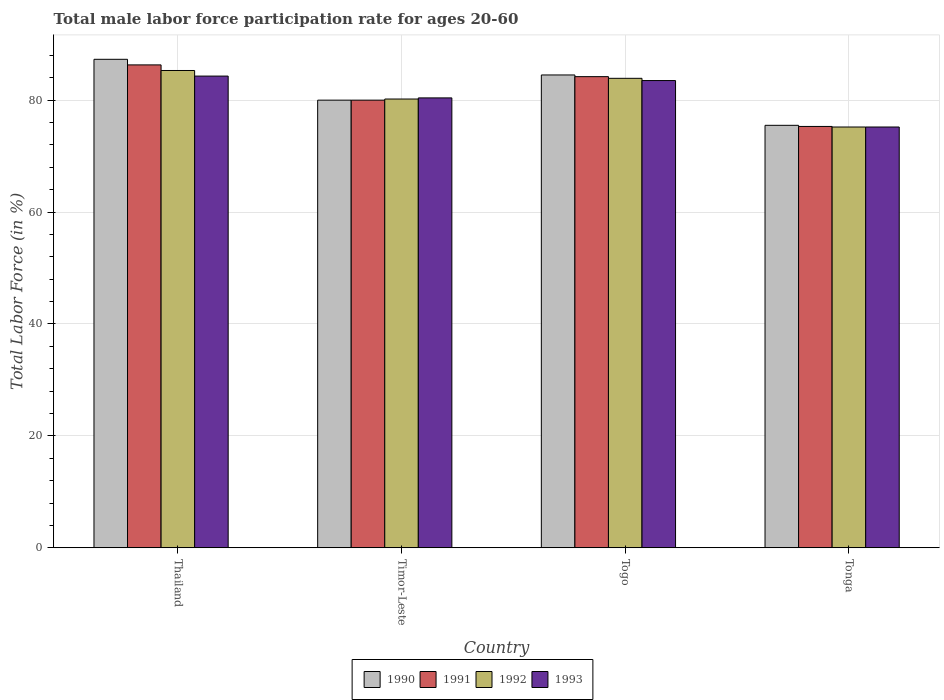How many groups of bars are there?
Offer a terse response. 4. What is the label of the 1st group of bars from the left?
Your answer should be compact. Thailand. In how many cases, is the number of bars for a given country not equal to the number of legend labels?
Provide a short and direct response. 0. What is the male labor force participation rate in 1991 in Thailand?
Offer a terse response. 86.3. Across all countries, what is the maximum male labor force participation rate in 1990?
Your response must be concise. 87.3. Across all countries, what is the minimum male labor force participation rate in 1992?
Provide a succinct answer. 75.2. In which country was the male labor force participation rate in 1993 maximum?
Provide a succinct answer. Thailand. In which country was the male labor force participation rate in 1993 minimum?
Give a very brief answer. Tonga. What is the total male labor force participation rate in 1990 in the graph?
Provide a succinct answer. 327.3. What is the difference between the male labor force participation rate in 1991 in Thailand and that in Togo?
Make the answer very short. 2.1. What is the difference between the male labor force participation rate in 1993 in Timor-Leste and the male labor force participation rate in 1992 in Togo?
Your answer should be compact. -3.5. What is the average male labor force participation rate in 1992 per country?
Make the answer very short. 81.15. What is the difference between the male labor force participation rate of/in 1992 and male labor force participation rate of/in 1991 in Thailand?
Provide a succinct answer. -1. In how many countries, is the male labor force participation rate in 1990 greater than 40 %?
Offer a very short reply. 4. What is the ratio of the male labor force participation rate in 1993 in Togo to that in Tonga?
Offer a very short reply. 1.11. Is the male labor force participation rate in 1993 in Timor-Leste less than that in Togo?
Make the answer very short. Yes. Is the difference between the male labor force participation rate in 1992 in Togo and Tonga greater than the difference between the male labor force participation rate in 1991 in Togo and Tonga?
Offer a very short reply. No. What is the difference between the highest and the lowest male labor force participation rate in 1992?
Your response must be concise. 10.1. In how many countries, is the male labor force participation rate in 1993 greater than the average male labor force participation rate in 1993 taken over all countries?
Offer a terse response. 2. Is it the case that in every country, the sum of the male labor force participation rate in 1991 and male labor force participation rate in 1992 is greater than the sum of male labor force participation rate in 1990 and male labor force participation rate in 1993?
Your answer should be compact. No. Is it the case that in every country, the sum of the male labor force participation rate in 1992 and male labor force participation rate in 1991 is greater than the male labor force participation rate in 1990?
Offer a very short reply. Yes. How many bars are there?
Your answer should be very brief. 16. Are all the bars in the graph horizontal?
Your answer should be very brief. No. Does the graph contain grids?
Your answer should be compact. Yes. Where does the legend appear in the graph?
Keep it short and to the point. Bottom center. How many legend labels are there?
Your answer should be very brief. 4. What is the title of the graph?
Ensure brevity in your answer.  Total male labor force participation rate for ages 20-60. Does "1971" appear as one of the legend labels in the graph?
Your response must be concise. No. What is the label or title of the X-axis?
Your response must be concise. Country. What is the Total Labor Force (in %) in 1990 in Thailand?
Provide a succinct answer. 87.3. What is the Total Labor Force (in %) in 1991 in Thailand?
Ensure brevity in your answer.  86.3. What is the Total Labor Force (in %) of 1992 in Thailand?
Offer a very short reply. 85.3. What is the Total Labor Force (in %) of 1993 in Thailand?
Provide a succinct answer. 84.3. What is the Total Labor Force (in %) in 1990 in Timor-Leste?
Your answer should be compact. 80. What is the Total Labor Force (in %) of 1992 in Timor-Leste?
Your response must be concise. 80.2. What is the Total Labor Force (in %) in 1993 in Timor-Leste?
Keep it short and to the point. 80.4. What is the Total Labor Force (in %) of 1990 in Togo?
Offer a terse response. 84.5. What is the Total Labor Force (in %) of 1991 in Togo?
Your answer should be very brief. 84.2. What is the Total Labor Force (in %) of 1992 in Togo?
Make the answer very short. 83.9. What is the Total Labor Force (in %) of 1993 in Togo?
Your answer should be compact. 83.5. What is the Total Labor Force (in %) of 1990 in Tonga?
Provide a short and direct response. 75.5. What is the Total Labor Force (in %) of 1991 in Tonga?
Keep it short and to the point. 75.3. What is the Total Labor Force (in %) of 1992 in Tonga?
Give a very brief answer. 75.2. What is the Total Labor Force (in %) of 1993 in Tonga?
Make the answer very short. 75.2. Across all countries, what is the maximum Total Labor Force (in %) in 1990?
Offer a very short reply. 87.3. Across all countries, what is the maximum Total Labor Force (in %) in 1991?
Make the answer very short. 86.3. Across all countries, what is the maximum Total Labor Force (in %) of 1992?
Keep it short and to the point. 85.3. Across all countries, what is the maximum Total Labor Force (in %) of 1993?
Give a very brief answer. 84.3. Across all countries, what is the minimum Total Labor Force (in %) of 1990?
Give a very brief answer. 75.5. Across all countries, what is the minimum Total Labor Force (in %) in 1991?
Ensure brevity in your answer.  75.3. Across all countries, what is the minimum Total Labor Force (in %) in 1992?
Offer a terse response. 75.2. Across all countries, what is the minimum Total Labor Force (in %) of 1993?
Ensure brevity in your answer.  75.2. What is the total Total Labor Force (in %) of 1990 in the graph?
Provide a succinct answer. 327.3. What is the total Total Labor Force (in %) of 1991 in the graph?
Give a very brief answer. 325.8. What is the total Total Labor Force (in %) in 1992 in the graph?
Offer a very short reply. 324.6. What is the total Total Labor Force (in %) of 1993 in the graph?
Provide a succinct answer. 323.4. What is the difference between the Total Labor Force (in %) in 1991 in Thailand and that in Timor-Leste?
Ensure brevity in your answer.  6.3. What is the difference between the Total Labor Force (in %) in 1992 in Thailand and that in Timor-Leste?
Offer a terse response. 5.1. What is the difference between the Total Labor Force (in %) of 1993 in Thailand and that in Timor-Leste?
Keep it short and to the point. 3.9. What is the difference between the Total Labor Force (in %) of 1991 in Thailand and that in Togo?
Provide a short and direct response. 2.1. What is the difference between the Total Labor Force (in %) of 1992 in Thailand and that in Togo?
Your answer should be very brief. 1.4. What is the difference between the Total Labor Force (in %) in 1993 in Thailand and that in Togo?
Give a very brief answer. 0.8. What is the difference between the Total Labor Force (in %) of 1990 in Thailand and that in Tonga?
Provide a short and direct response. 11.8. What is the difference between the Total Labor Force (in %) in 1991 in Thailand and that in Tonga?
Your response must be concise. 11. What is the difference between the Total Labor Force (in %) of 1992 in Thailand and that in Tonga?
Offer a terse response. 10.1. What is the difference between the Total Labor Force (in %) in 1990 in Timor-Leste and that in Togo?
Keep it short and to the point. -4.5. What is the difference between the Total Labor Force (in %) of 1992 in Timor-Leste and that in Togo?
Keep it short and to the point. -3.7. What is the difference between the Total Labor Force (in %) in 1993 in Timor-Leste and that in Togo?
Provide a succinct answer. -3.1. What is the difference between the Total Labor Force (in %) of 1991 in Timor-Leste and that in Tonga?
Your response must be concise. 4.7. What is the difference between the Total Labor Force (in %) in 1992 in Timor-Leste and that in Tonga?
Your answer should be compact. 5. What is the difference between the Total Labor Force (in %) of 1993 in Timor-Leste and that in Tonga?
Keep it short and to the point. 5.2. What is the difference between the Total Labor Force (in %) of 1990 in Togo and that in Tonga?
Provide a succinct answer. 9. What is the difference between the Total Labor Force (in %) of 1991 in Togo and that in Tonga?
Keep it short and to the point. 8.9. What is the difference between the Total Labor Force (in %) in 1990 in Thailand and the Total Labor Force (in %) in 1992 in Timor-Leste?
Provide a short and direct response. 7.1. What is the difference between the Total Labor Force (in %) in 1991 in Thailand and the Total Labor Force (in %) in 1992 in Timor-Leste?
Give a very brief answer. 6.1. What is the difference between the Total Labor Force (in %) of 1991 in Thailand and the Total Labor Force (in %) of 1993 in Timor-Leste?
Give a very brief answer. 5.9. What is the difference between the Total Labor Force (in %) of 1992 in Thailand and the Total Labor Force (in %) of 1993 in Timor-Leste?
Provide a short and direct response. 4.9. What is the difference between the Total Labor Force (in %) in 1990 in Thailand and the Total Labor Force (in %) in 1992 in Togo?
Provide a succinct answer. 3.4. What is the difference between the Total Labor Force (in %) in 1990 in Thailand and the Total Labor Force (in %) in 1993 in Togo?
Keep it short and to the point. 3.8. What is the difference between the Total Labor Force (in %) in 1992 in Thailand and the Total Labor Force (in %) in 1993 in Togo?
Your answer should be very brief. 1.8. What is the difference between the Total Labor Force (in %) of 1990 in Thailand and the Total Labor Force (in %) of 1991 in Tonga?
Provide a short and direct response. 12. What is the difference between the Total Labor Force (in %) of 1991 in Thailand and the Total Labor Force (in %) of 1992 in Tonga?
Provide a short and direct response. 11.1. What is the difference between the Total Labor Force (in %) of 1991 in Thailand and the Total Labor Force (in %) of 1993 in Tonga?
Make the answer very short. 11.1. What is the difference between the Total Labor Force (in %) in 1990 in Timor-Leste and the Total Labor Force (in %) in 1993 in Togo?
Keep it short and to the point. -3.5. What is the difference between the Total Labor Force (in %) of 1991 in Timor-Leste and the Total Labor Force (in %) of 1992 in Togo?
Offer a terse response. -3.9. What is the difference between the Total Labor Force (in %) in 1991 in Timor-Leste and the Total Labor Force (in %) in 1993 in Togo?
Your response must be concise. -3.5. What is the difference between the Total Labor Force (in %) of 1990 in Timor-Leste and the Total Labor Force (in %) of 1992 in Tonga?
Give a very brief answer. 4.8. What is the difference between the Total Labor Force (in %) of 1990 in Togo and the Total Labor Force (in %) of 1991 in Tonga?
Give a very brief answer. 9.2. What is the difference between the Total Labor Force (in %) of 1990 in Togo and the Total Labor Force (in %) of 1992 in Tonga?
Provide a short and direct response. 9.3. What is the difference between the Total Labor Force (in %) in 1990 in Togo and the Total Labor Force (in %) in 1993 in Tonga?
Provide a succinct answer. 9.3. What is the difference between the Total Labor Force (in %) of 1991 in Togo and the Total Labor Force (in %) of 1993 in Tonga?
Provide a succinct answer. 9. What is the difference between the Total Labor Force (in %) of 1992 in Togo and the Total Labor Force (in %) of 1993 in Tonga?
Offer a very short reply. 8.7. What is the average Total Labor Force (in %) in 1990 per country?
Your answer should be very brief. 81.83. What is the average Total Labor Force (in %) in 1991 per country?
Offer a very short reply. 81.45. What is the average Total Labor Force (in %) in 1992 per country?
Offer a very short reply. 81.15. What is the average Total Labor Force (in %) in 1993 per country?
Provide a succinct answer. 80.85. What is the difference between the Total Labor Force (in %) of 1990 and Total Labor Force (in %) of 1992 in Thailand?
Your answer should be very brief. 2. What is the difference between the Total Labor Force (in %) of 1990 and Total Labor Force (in %) of 1993 in Thailand?
Your answer should be very brief. 3. What is the difference between the Total Labor Force (in %) of 1991 and Total Labor Force (in %) of 1993 in Thailand?
Your answer should be very brief. 2. What is the difference between the Total Labor Force (in %) of 1992 and Total Labor Force (in %) of 1993 in Thailand?
Your answer should be very brief. 1. What is the difference between the Total Labor Force (in %) of 1990 and Total Labor Force (in %) of 1993 in Timor-Leste?
Provide a succinct answer. -0.4. What is the difference between the Total Labor Force (in %) of 1991 and Total Labor Force (in %) of 1992 in Timor-Leste?
Keep it short and to the point. -0.2. What is the difference between the Total Labor Force (in %) of 1991 and Total Labor Force (in %) of 1993 in Timor-Leste?
Offer a very short reply. -0.4. What is the difference between the Total Labor Force (in %) in 1990 and Total Labor Force (in %) in 1993 in Togo?
Your answer should be compact. 1. What is the difference between the Total Labor Force (in %) of 1992 and Total Labor Force (in %) of 1993 in Togo?
Offer a very short reply. 0.4. What is the difference between the Total Labor Force (in %) of 1990 and Total Labor Force (in %) of 1991 in Tonga?
Ensure brevity in your answer.  0.2. What is the difference between the Total Labor Force (in %) in 1990 and Total Labor Force (in %) in 1993 in Tonga?
Give a very brief answer. 0.3. What is the difference between the Total Labor Force (in %) in 1991 and Total Labor Force (in %) in 1992 in Tonga?
Give a very brief answer. 0.1. What is the ratio of the Total Labor Force (in %) in 1990 in Thailand to that in Timor-Leste?
Provide a short and direct response. 1.09. What is the ratio of the Total Labor Force (in %) of 1991 in Thailand to that in Timor-Leste?
Your answer should be compact. 1.08. What is the ratio of the Total Labor Force (in %) in 1992 in Thailand to that in Timor-Leste?
Keep it short and to the point. 1.06. What is the ratio of the Total Labor Force (in %) in 1993 in Thailand to that in Timor-Leste?
Provide a succinct answer. 1.05. What is the ratio of the Total Labor Force (in %) of 1990 in Thailand to that in Togo?
Offer a terse response. 1.03. What is the ratio of the Total Labor Force (in %) in 1991 in Thailand to that in Togo?
Your answer should be compact. 1.02. What is the ratio of the Total Labor Force (in %) in 1992 in Thailand to that in Togo?
Your answer should be very brief. 1.02. What is the ratio of the Total Labor Force (in %) of 1993 in Thailand to that in Togo?
Provide a succinct answer. 1.01. What is the ratio of the Total Labor Force (in %) of 1990 in Thailand to that in Tonga?
Keep it short and to the point. 1.16. What is the ratio of the Total Labor Force (in %) of 1991 in Thailand to that in Tonga?
Your response must be concise. 1.15. What is the ratio of the Total Labor Force (in %) in 1992 in Thailand to that in Tonga?
Provide a succinct answer. 1.13. What is the ratio of the Total Labor Force (in %) of 1993 in Thailand to that in Tonga?
Offer a very short reply. 1.12. What is the ratio of the Total Labor Force (in %) of 1990 in Timor-Leste to that in Togo?
Your answer should be very brief. 0.95. What is the ratio of the Total Labor Force (in %) of 1991 in Timor-Leste to that in Togo?
Provide a succinct answer. 0.95. What is the ratio of the Total Labor Force (in %) of 1992 in Timor-Leste to that in Togo?
Your response must be concise. 0.96. What is the ratio of the Total Labor Force (in %) in 1993 in Timor-Leste to that in Togo?
Keep it short and to the point. 0.96. What is the ratio of the Total Labor Force (in %) in 1990 in Timor-Leste to that in Tonga?
Your answer should be very brief. 1.06. What is the ratio of the Total Labor Force (in %) of 1991 in Timor-Leste to that in Tonga?
Your answer should be very brief. 1.06. What is the ratio of the Total Labor Force (in %) of 1992 in Timor-Leste to that in Tonga?
Give a very brief answer. 1.07. What is the ratio of the Total Labor Force (in %) in 1993 in Timor-Leste to that in Tonga?
Your response must be concise. 1.07. What is the ratio of the Total Labor Force (in %) of 1990 in Togo to that in Tonga?
Provide a succinct answer. 1.12. What is the ratio of the Total Labor Force (in %) in 1991 in Togo to that in Tonga?
Your answer should be very brief. 1.12. What is the ratio of the Total Labor Force (in %) in 1992 in Togo to that in Tonga?
Your answer should be compact. 1.12. What is the ratio of the Total Labor Force (in %) in 1993 in Togo to that in Tonga?
Ensure brevity in your answer.  1.11. What is the difference between the highest and the second highest Total Labor Force (in %) in 1991?
Your response must be concise. 2.1. What is the difference between the highest and the second highest Total Labor Force (in %) of 1992?
Your answer should be very brief. 1.4. What is the difference between the highest and the second highest Total Labor Force (in %) of 1993?
Your answer should be very brief. 0.8. What is the difference between the highest and the lowest Total Labor Force (in %) of 1990?
Keep it short and to the point. 11.8. What is the difference between the highest and the lowest Total Labor Force (in %) of 1992?
Provide a short and direct response. 10.1. 